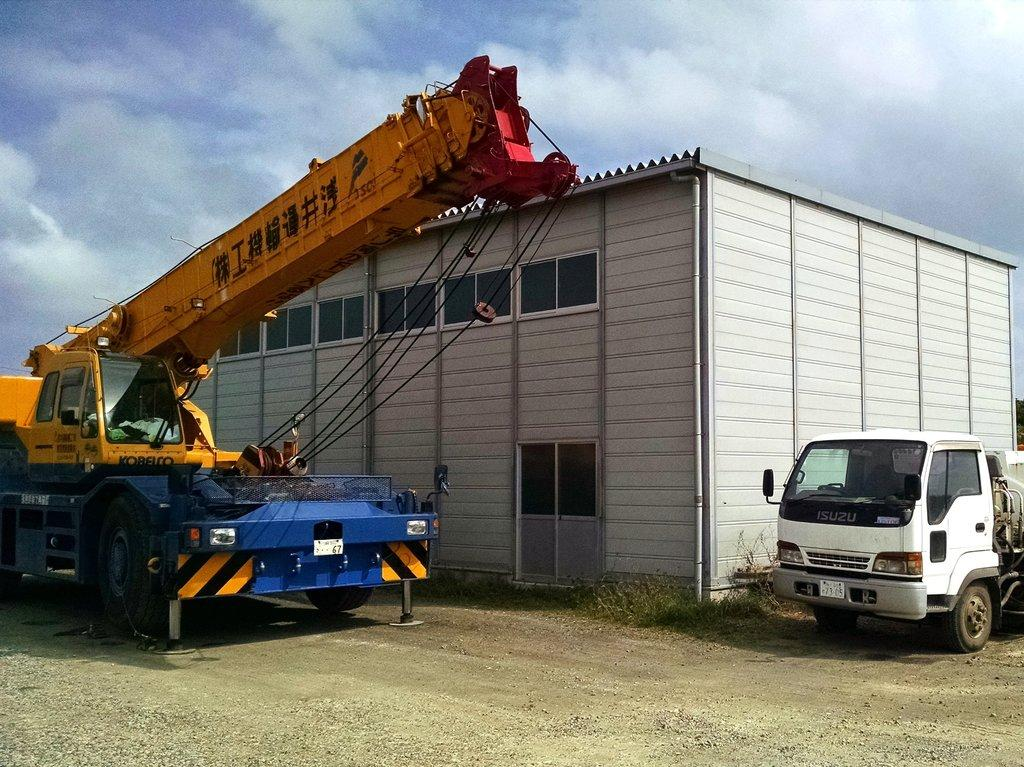What is the main subject of the image? The main subject of the image is a crane. What can be seen behind the crane? There appears to be a house behind the crane. What else is visible in the image? There is a vehicle on the right side of the image. Can you describe the fight between the crane and the vehicle in the image? There is no fight between the crane and the vehicle in the image; they are simply objects in the scene. What type of fire can be seen coming from the crane in the image? There is no fire present in the image; it features a crane, a house, and a vehicle. 